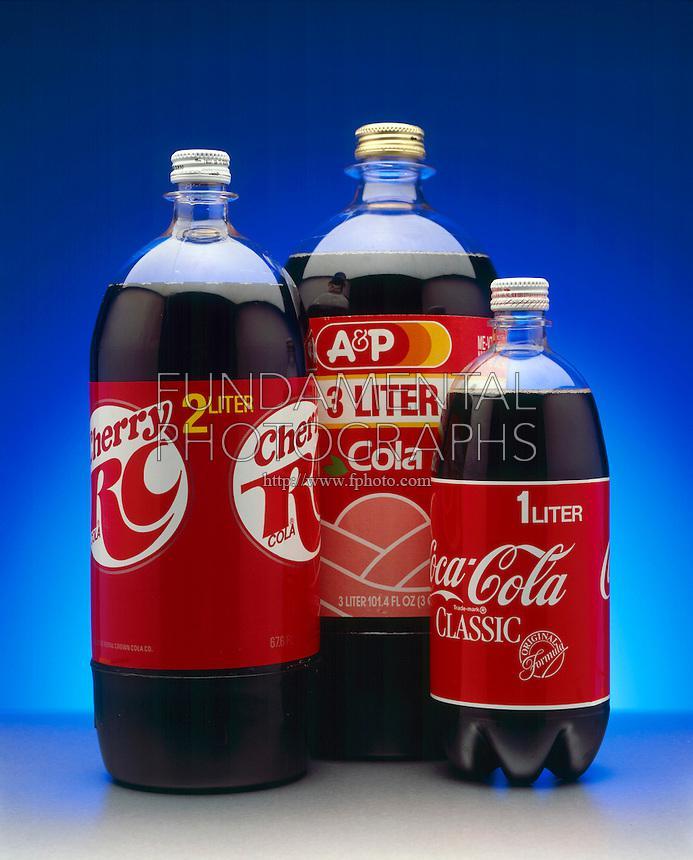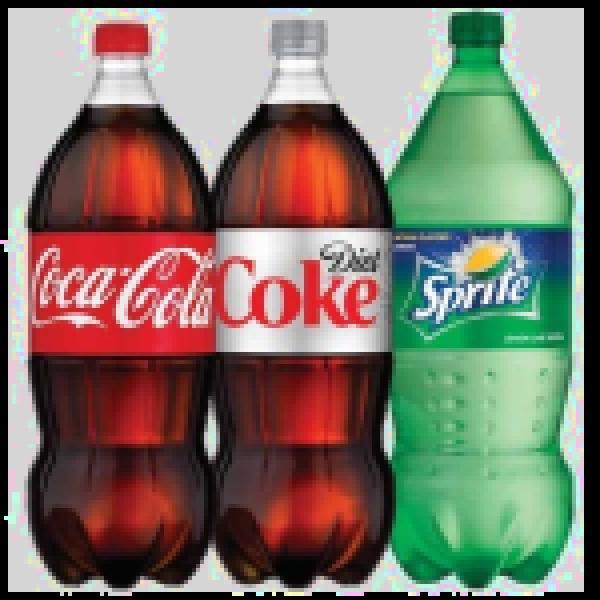The first image is the image on the left, the second image is the image on the right. Assess this claim about the two images: "There is a total of six bottles". Correct or not? Answer yes or no. Yes. The first image is the image on the left, the second image is the image on the right. Given the left and right images, does the statement "There are the same number of bottles in each of the images." hold true? Answer yes or no. Yes. 